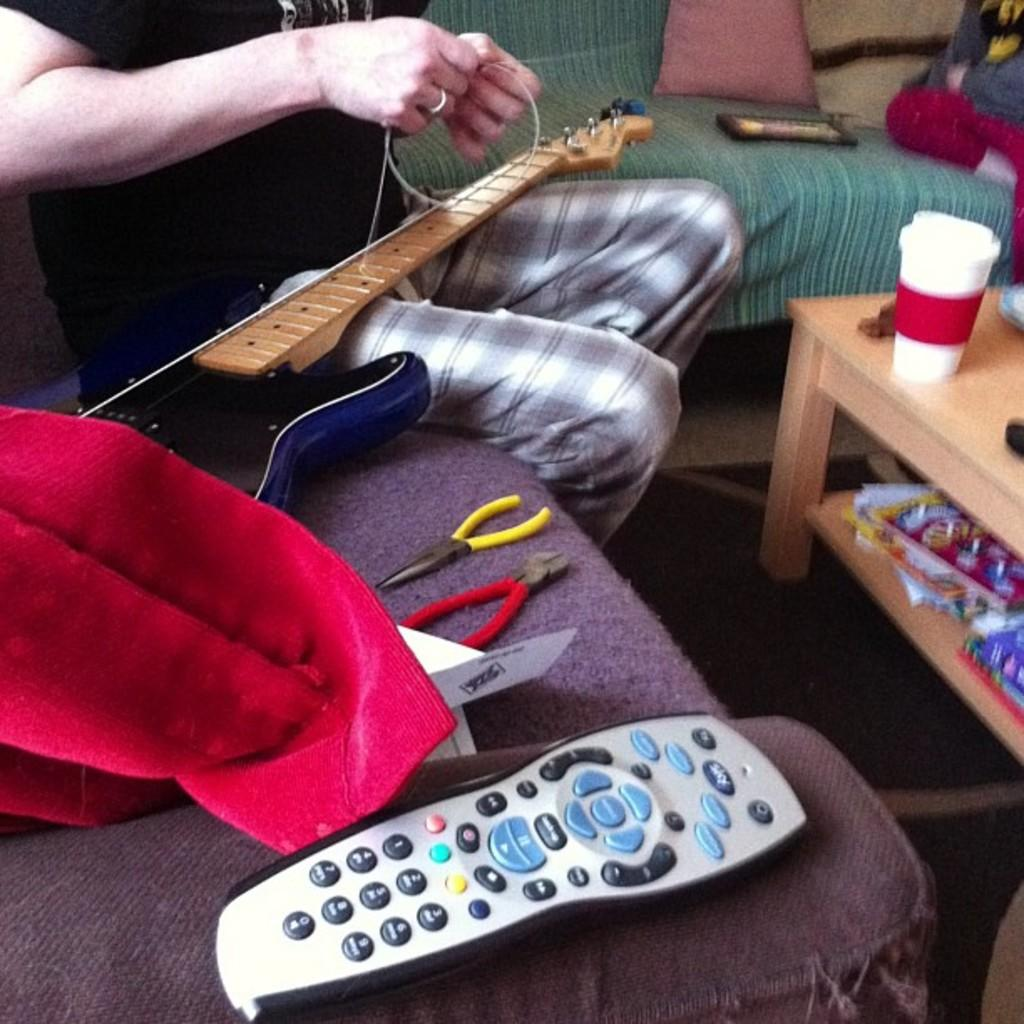<image>
Share a concise interpretation of the image provided. Someone stringing a guitar on a couch next to plyers and a remote control. 